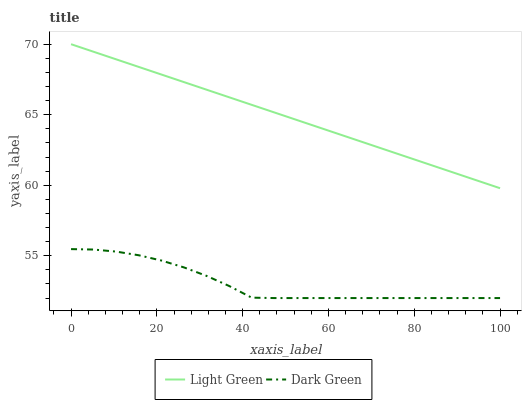Does Dark Green have the minimum area under the curve?
Answer yes or no. Yes. Does Light Green have the maximum area under the curve?
Answer yes or no. Yes. Does Dark Green have the maximum area under the curve?
Answer yes or no. No. Is Light Green the smoothest?
Answer yes or no. Yes. Is Dark Green the roughest?
Answer yes or no. Yes. Is Dark Green the smoothest?
Answer yes or no. No. Does Light Green have the highest value?
Answer yes or no. Yes. Does Dark Green have the highest value?
Answer yes or no. No. Is Dark Green less than Light Green?
Answer yes or no. Yes. Is Light Green greater than Dark Green?
Answer yes or no. Yes. Does Dark Green intersect Light Green?
Answer yes or no. No. 